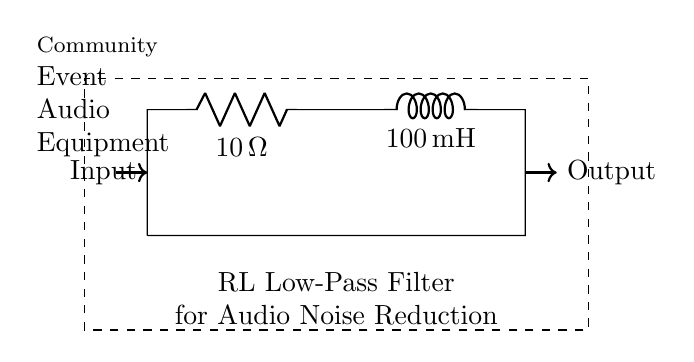What components are in this circuit? The circuit contains a resistor and an inductor, as indicated by the labels R and L in the diagram.
Answer: Resistor and Inductor What is the resistance value in this circuit? The resistance value is specified next to the resistor label R as 10 ohms.
Answer: 10 ohms What is the inductance value of the inductor? The inductance value is specified next to the inductor label L as 100 millihenries.
Answer: 100 millihenries What type of filter is represented by this circuit? The circuit is labeled as an RL low-pass filter, indicating its function to allow low frequencies to pass while attenuating higher frequencies.
Answer: RL low-pass filter How does this circuit reduce noise in audio equipment? The RL filter allows low-frequency audio signals to pass while reducing high-frequency noise, effectively filtering out unwanted noise while maintaining the desired audio signal.
Answer: By filtering high-frequency noise What is the expected behavior of the output signal when noise is present? The output signal should have a reduced amplitude for high-frequency components, leading to a clearer audio signal with minimal noise interference.
Answer: Reduced amplitude for high frequencies What is the primary purpose of the inductor in this circuit? The inductor's primary purpose is to store energy in a magnetic field and oppose changes in current, which helps in reducing the rate of change of voltage across it, thus attenuating high-frequency signals.
Answer: To store energy and oppose current changes 